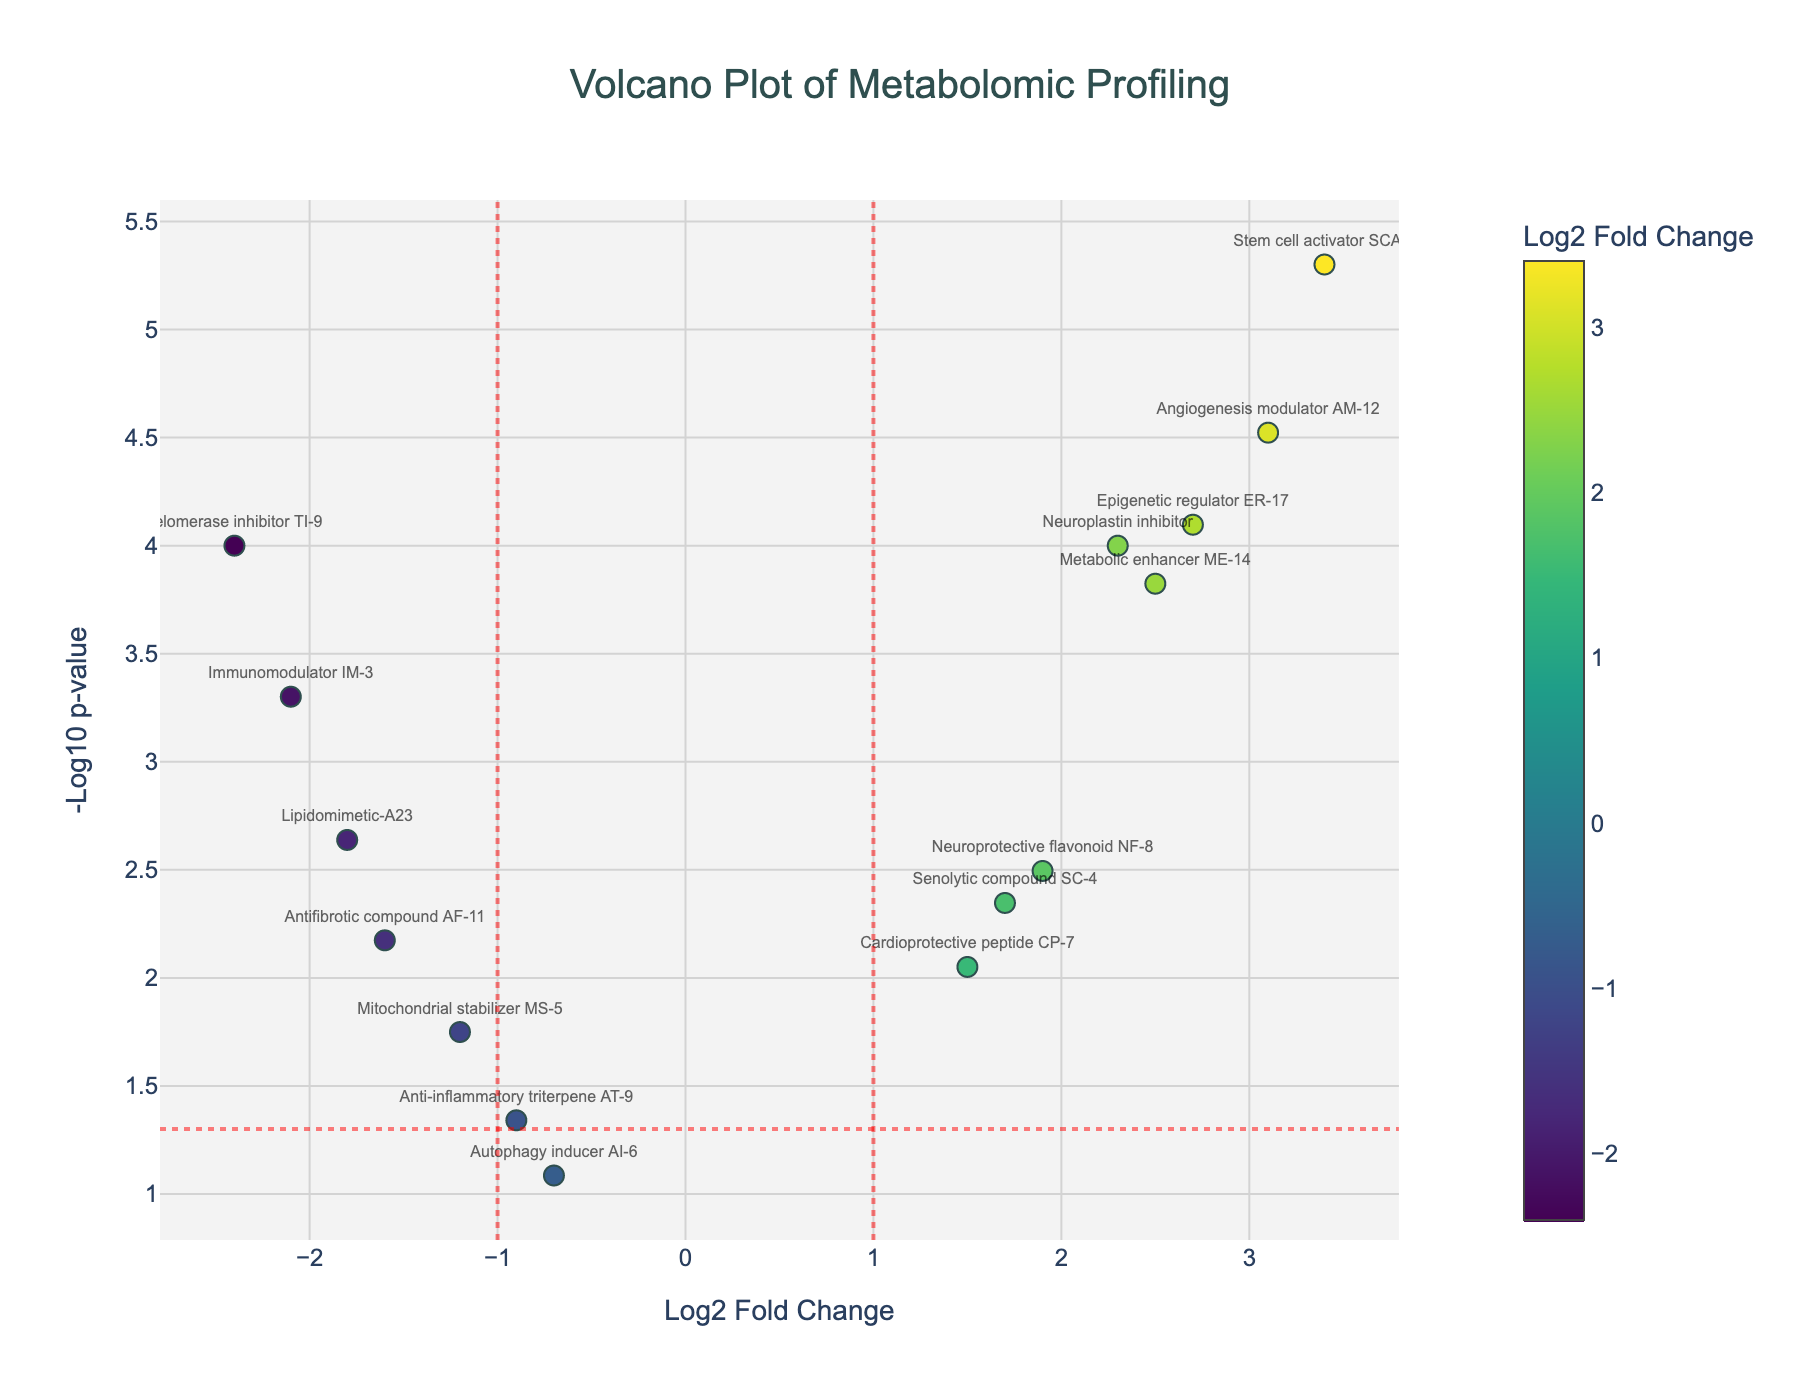How many compounds are statistically significant at p < 0.05? Statistically significant compounds at p < 0.05 will fall above the horizontal red dotted line at -log10(p-value) = 1.3. Count the number of points above this line.
Answer: 13 Which compound has the highest log2 fold change? The highest log2 fold change is represented by the point farthest to the right. Look for the compound name at this position.
Answer: Stem cell activator SCA-2 What is the name of the compound represented by the most statistically significant p-value? The most statistically significant p-value corresponds to the highest -log10(p-value) on the y-axis. Identify the compound name at this position.
Answer: Stem cell activator SCA-2 Which compounds show a negative log2 fold change and are statistically significant? Statistically significant compounds with negative log2 fold changes are found to the left of the vertical red dotted lines at x = -1 and above the horizontal red dotted line at -log10(p-value) = 1.3. Identify their names.
Answer: Lipidomimetic-A23, Mitochondrial stabilizer MS-5, Immunomodulator IM-3, Antifibrotic compound AF-11, Telomerase inhibitor TI-9 What is the average log2 fold change of compounds that are statistically significant? First, identify compounds above the horizontal red dotted line. Next, calculate the average log2 fold change of these points.
Answer: (Sum of log2 fold changes of significant compounds) / 13 How many compounds have a log2 fold change greater than 2 and are statistically significant? Identify points with log2 fold change greater than 2 (right side of the vertical red dotted line at x = 1) and above the horizontal red dotted line at -log10(p-value) = 1.3. Count these points.
Answer: 5 Which is the compound with the smallest log2 fold change among the statistically significant ones? Among points above the horizontal red dotted line, find the one with the smallest log2 fold change value (farthest left).
Answer: Immunomodulator IM-3 Are there more upregulated (positive log2 fold change) or downregulated compounds (negative log2 fold change) that are statistically significant? Count the number of compounds with positive log2 fold change above the horizontal red dotted line, then count those with negative log2 fold change above the same line. Compare the two counts.
Answer: Upregulated Which compound shows the highest log2 fold change among those that are not statistically significant? Identify compounds below the horizontal red dotted line for -log10(p-value). Find the one with the highest log2 fold change.
Answer: Autophagy inducer AI-6 